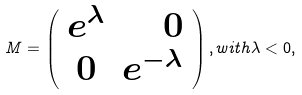<formula> <loc_0><loc_0><loc_500><loc_500>M = \left ( \begin{array} { c r } e ^ { \lambda } & 0 \\ 0 & e ^ { - \lambda } \end{array} \right ) , w i t h \lambda < 0 ,</formula> 